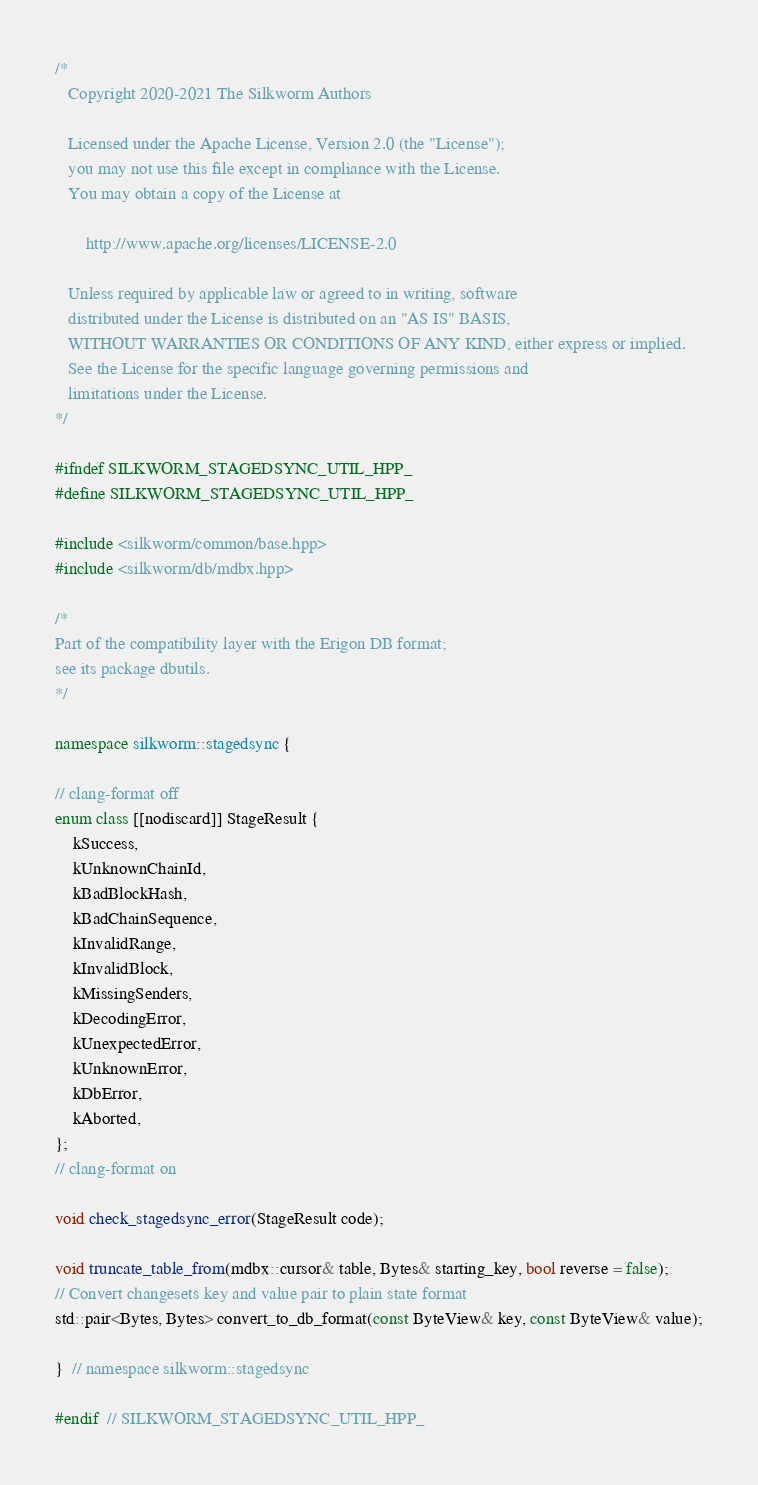<code> <loc_0><loc_0><loc_500><loc_500><_C++_>/*
   Copyright 2020-2021 The Silkworm Authors

   Licensed under the Apache License, Version 2.0 (the "License");
   you may not use this file except in compliance with the License.
   You may obtain a copy of the License at

       http://www.apache.org/licenses/LICENSE-2.0

   Unless required by applicable law or agreed to in writing, software
   distributed under the License is distributed on an "AS IS" BASIS,
   WITHOUT WARRANTIES OR CONDITIONS OF ANY KIND, either express or implied.
   See the License for the specific language governing permissions and
   limitations under the License.
*/

#ifndef SILKWORM_STAGEDSYNC_UTIL_HPP_
#define SILKWORM_STAGEDSYNC_UTIL_HPP_

#include <silkworm/common/base.hpp>
#include <silkworm/db/mdbx.hpp>

/*
Part of the compatibility layer with the Erigon DB format;
see its package dbutils.
*/

namespace silkworm::stagedsync {

// clang-format off
enum class [[nodiscard]] StageResult {
    kSuccess,
    kUnknownChainId,
    kBadBlockHash,
    kBadChainSequence,
    kInvalidRange,
    kInvalidBlock,
    kMissingSenders,
    kDecodingError,
    kUnexpectedError,
    kUnknownError,
    kDbError,
    kAborted,
};
// clang-format on

void check_stagedsync_error(StageResult code);

void truncate_table_from(mdbx::cursor& table, Bytes& starting_key, bool reverse = false);
// Convert changesets key and value pair to plain state format
std::pair<Bytes, Bytes> convert_to_db_format(const ByteView& key, const ByteView& value);

}  // namespace silkworm::stagedsync

#endif  // SILKWORM_STAGEDSYNC_UTIL_HPP_
</code> 